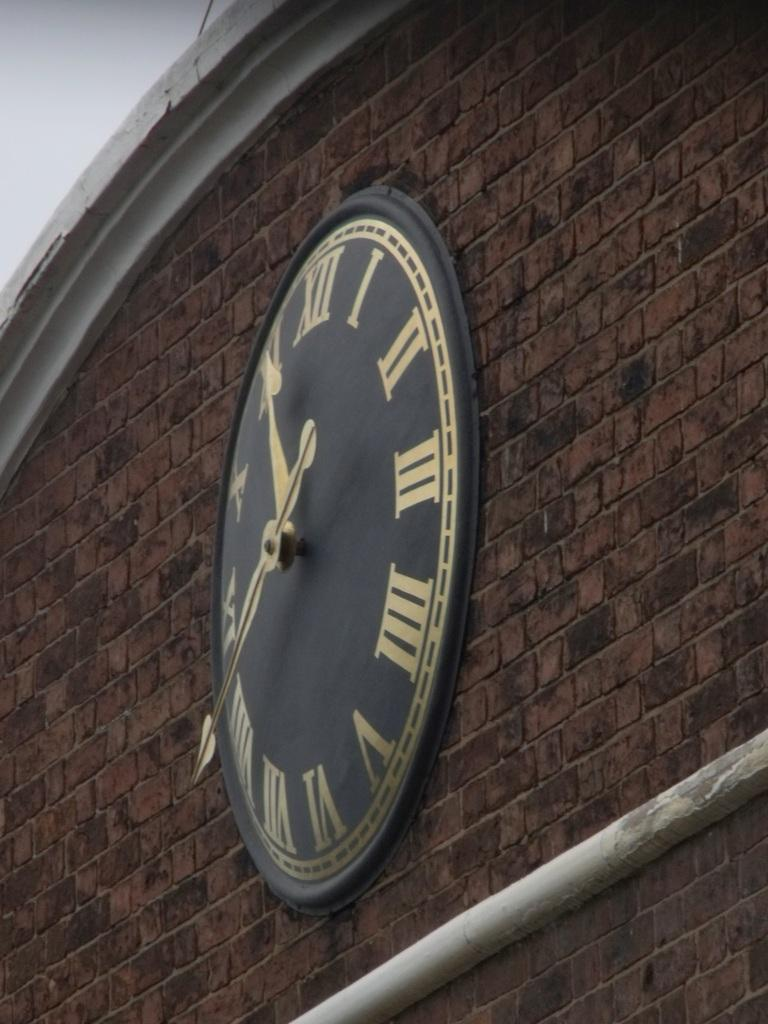Provide a one-sentence caption for the provided image. Roman numeral clock with the hands at 11:40 on a brick wall. 